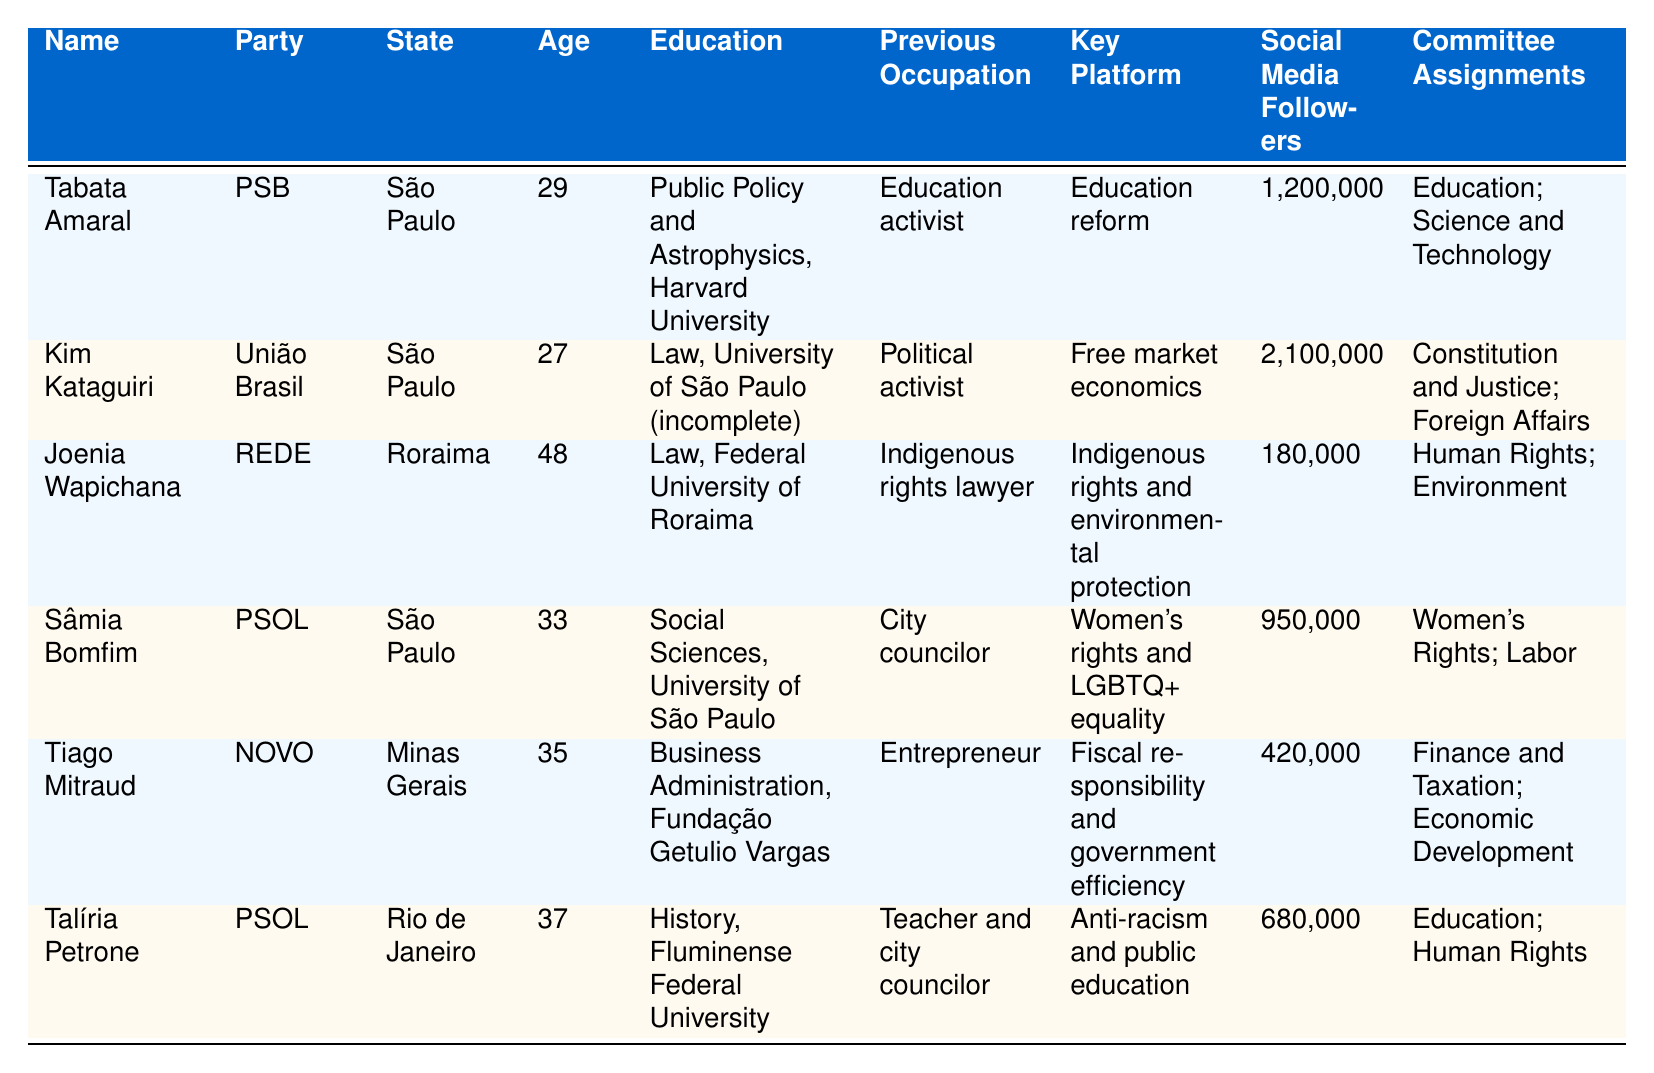What is the highest number of social media followers among the legislators? By reviewing the "Social Media Followers" column, Kim Kataguiri has 2,100,000 followers, which is the highest compared to other legislators.
Answer: 2,100,000 Which legislator has a background in Astrophysics? The "Education" column shows that Tabata Amaral studied Public Policy and Astrophysics at Harvard University, making her the only legislator with that background.
Answer: Tabata Amaral How many legislators are from the state of São Paulo? Looking at the "State" column, there are four legislators listed from São Paulo: Tabata Amaral, Kim Kataguiri, Sâmia Bomfim, and Tiago Mitraud.
Answer: 4 Which party does Joenia Wapichana belong to? Referring to the "Party" column, Joenia Wapichana is affiliated with the REDE party.
Answer: REDE What is the average age of the legislators listed? The ages of the legislators are 29, 27, 48, 33, 35, and 37. Summing these gives 29 + 27 + 48 + 33 + 35 + 37 = 209. Dividing by 6 (the number of legislators), the average age is 34.83, rounded to 35.
Answer: 35 Does any legislator have experience as a teacher? From the "Previous Occupation" column, Talíria Petrone is listed as having worked as a teacher, confirming that at least one legislator has that experience.
Answer: Yes Which committee assignment is common for legislators from PSOL? Both Sâmia Bomfim and Talíria Petrone, who are from the PSOL party, are assigned to the "Education" committee, indicating this committee's association with PSOL legislators.
Answer: Education What is the key platform of Tiago Mitraud? The "Key Platform" column shows that Tiago Mitraud's focus is on fiscal responsibility and government efficiency.
Answer: Fiscal responsibility and government efficiency Is it true that all legislators have a university education? By checking the "Education" column, we see that Kim Kataguiri's education in Law at the University of São Paulo is labeled as incomplete, indicating that not all have completed university education.
Answer: No Which legislator is focused on women's rights? Sâmia Bomfim's key platform emphasizes women's rights and LGBTQ+ equality, clearly indicating her focus area.
Answer: Sâmia Bomfim 